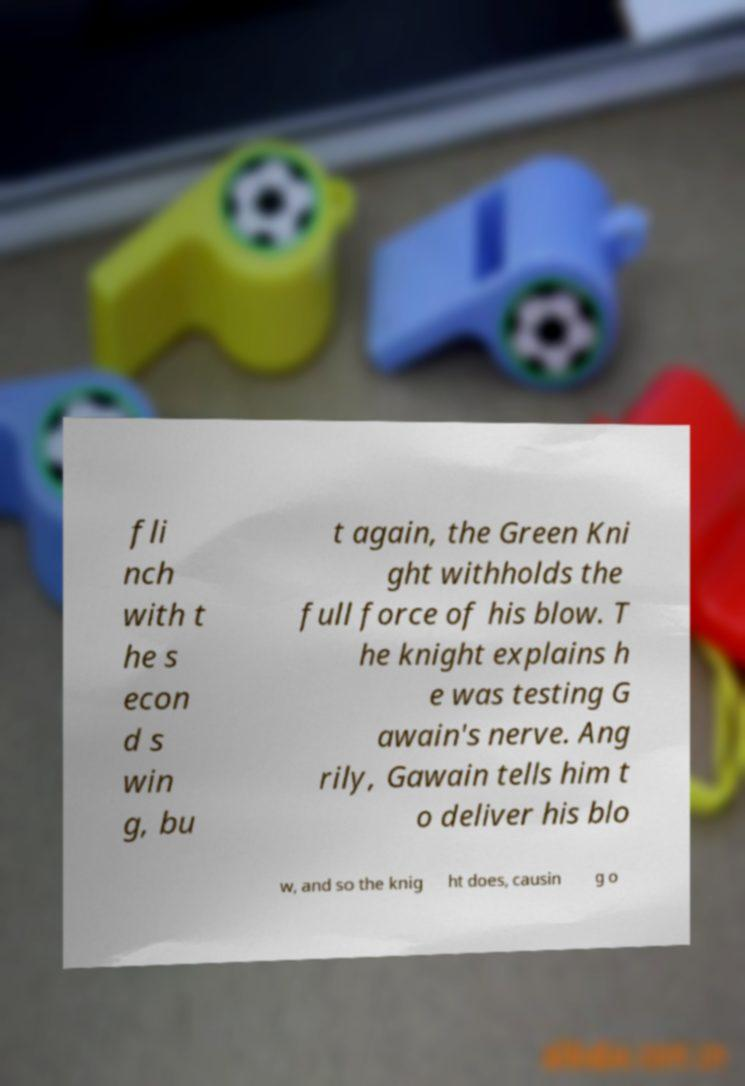What messages or text are displayed in this image? I need them in a readable, typed format. fli nch with t he s econ d s win g, bu t again, the Green Kni ght withholds the full force of his blow. T he knight explains h e was testing G awain's nerve. Ang rily, Gawain tells him t o deliver his blo w, and so the knig ht does, causin g o 